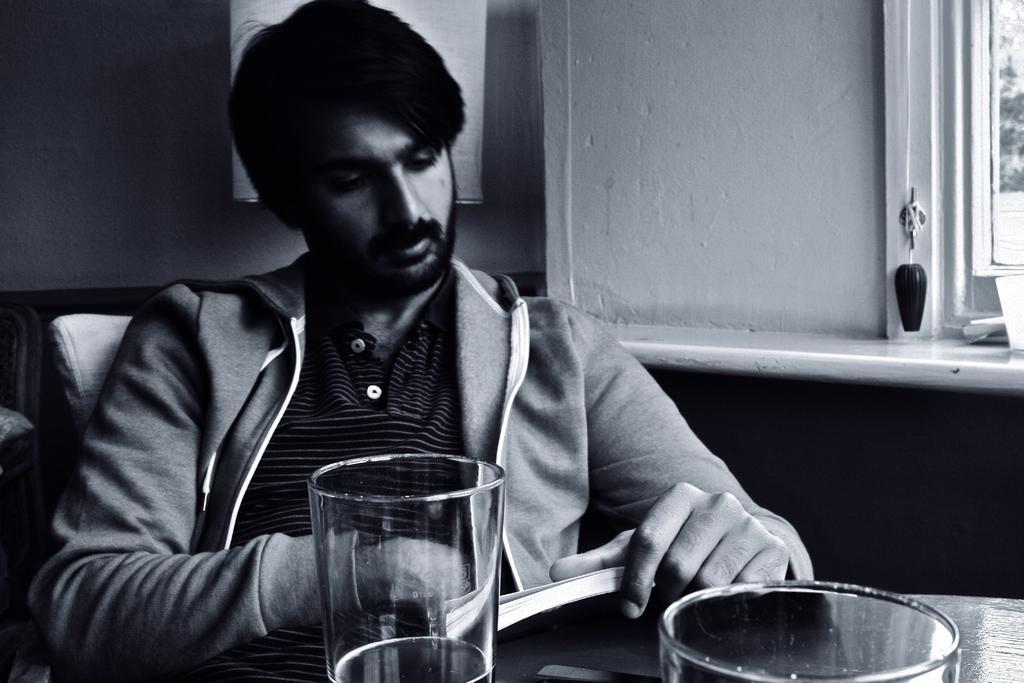Can you describe this image briefly? In the image we can see a man sitting, he is wearing clothes and holding a book in his hand. In front of him there is a table, on the table there are glasses, this is a window and an object. 